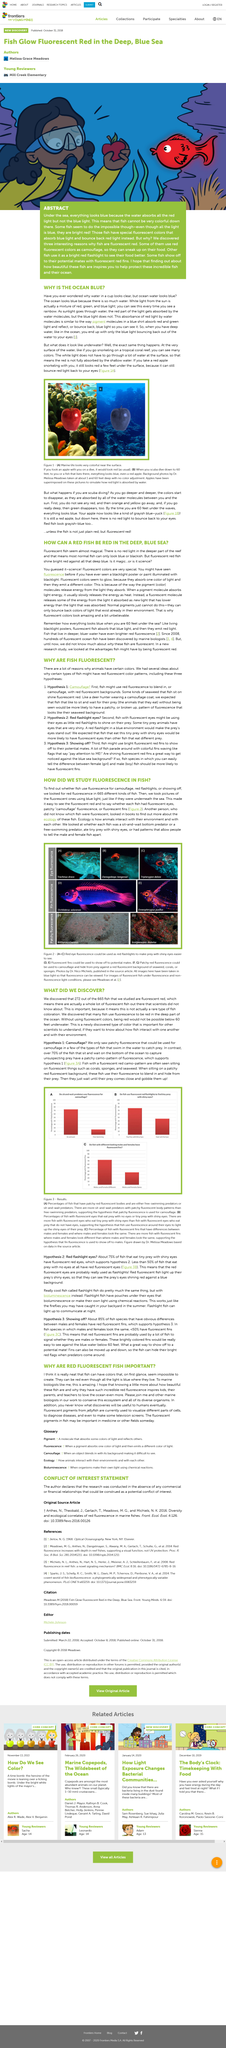Draw attention to some important aspects in this diagram. As a result of sunlight passing through water, a significant portion of the red light is absorbed by the water. We discovered that fish is an animal that is known for its aquatic habitats and its ability to swim. The reason the ocean appears blue is due to the vast amount of water in it. The photographs taken underwater made it easy to observe the fluorescent red on the fish, enabling the researcher to determine if the fish had fluorescent eyes, patches of camouflage fluorescence, or fluorescent fins. To capture underwater photos of fish, blue light was utilized as the light source. 